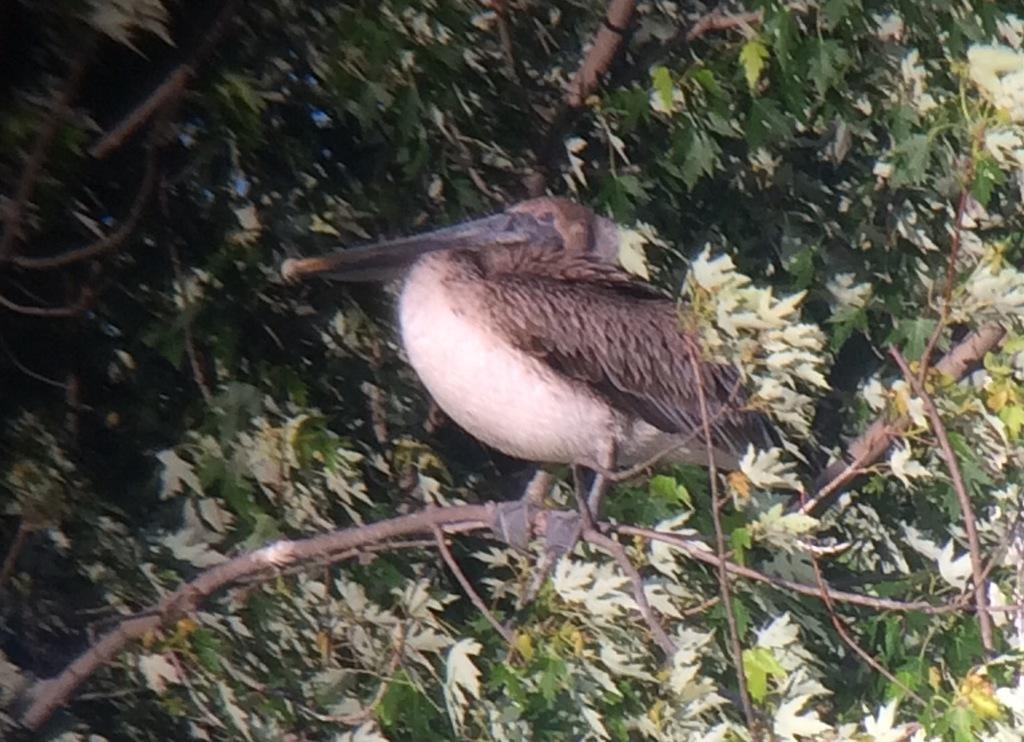What is the main subject of the image? There is a bird in the center of the image. Where is the bird located in the image? The bird is on a branch. What else can be seen in the image besides the bird? There are leaves visible in the image. What type of caption is written below the bird in the image? There is no caption written below the bird in the image. How does the bird's song affect the acoustics in the image? The image does not provide any information about the bird's song or the acoustics in the scene. 